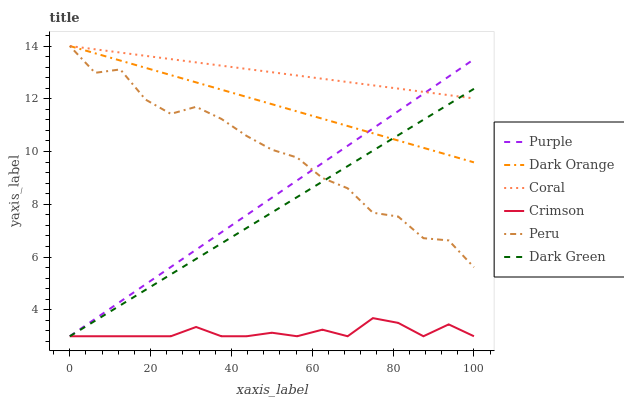Does Crimson have the minimum area under the curve?
Answer yes or no. Yes. Does Coral have the maximum area under the curve?
Answer yes or no. Yes. Does Purple have the minimum area under the curve?
Answer yes or no. No. Does Purple have the maximum area under the curve?
Answer yes or no. No. Is Purple the smoothest?
Answer yes or no. Yes. Is Peru the roughest?
Answer yes or no. Yes. Is Coral the smoothest?
Answer yes or no. No. Is Coral the roughest?
Answer yes or no. No. Does Purple have the lowest value?
Answer yes or no. Yes. Does Coral have the lowest value?
Answer yes or no. No. Does Peru have the highest value?
Answer yes or no. Yes. Does Purple have the highest value?
Answer yes or no. No. Is Crimson less than Coral?
Answer yes or no. Yes. Is Coral greater than Crimson?
Answer yes or no. Yes. Does Dark Green intersect Dark Orange?
Answer yes or no. Yes. Is Dark Green less than Dark Orange?
Answer yes or no. No. Is Dark Green greater than Dark Orange?
Answer yes or no. No. Does Crimson intersect Coral?
Answer yes or no. No. 